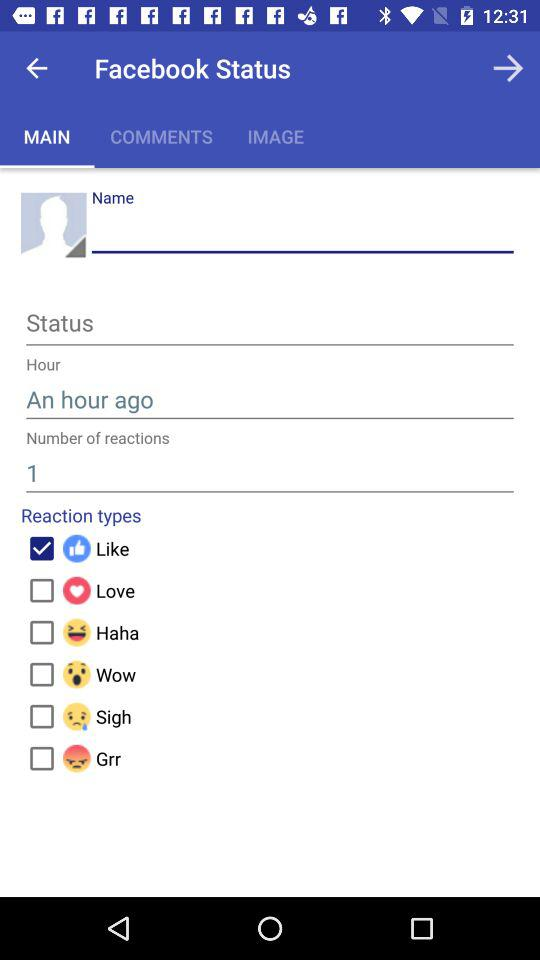How many reactions are there in total?
Answer the question using a single word or phrase. 1 